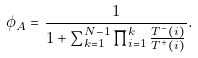Convert formula to latex. <formula><loc_0><loc_0><loc_500><loc_500>\phi _ { A } = \frac { 1 } { 1 + \sum _ { k = 1 } ^ { N - 1 } \prod _ { i = 1 } ^ { k } \frac { T ^ { - } ( i ) } { T ^ { + } ( i ) } } .</formula> 